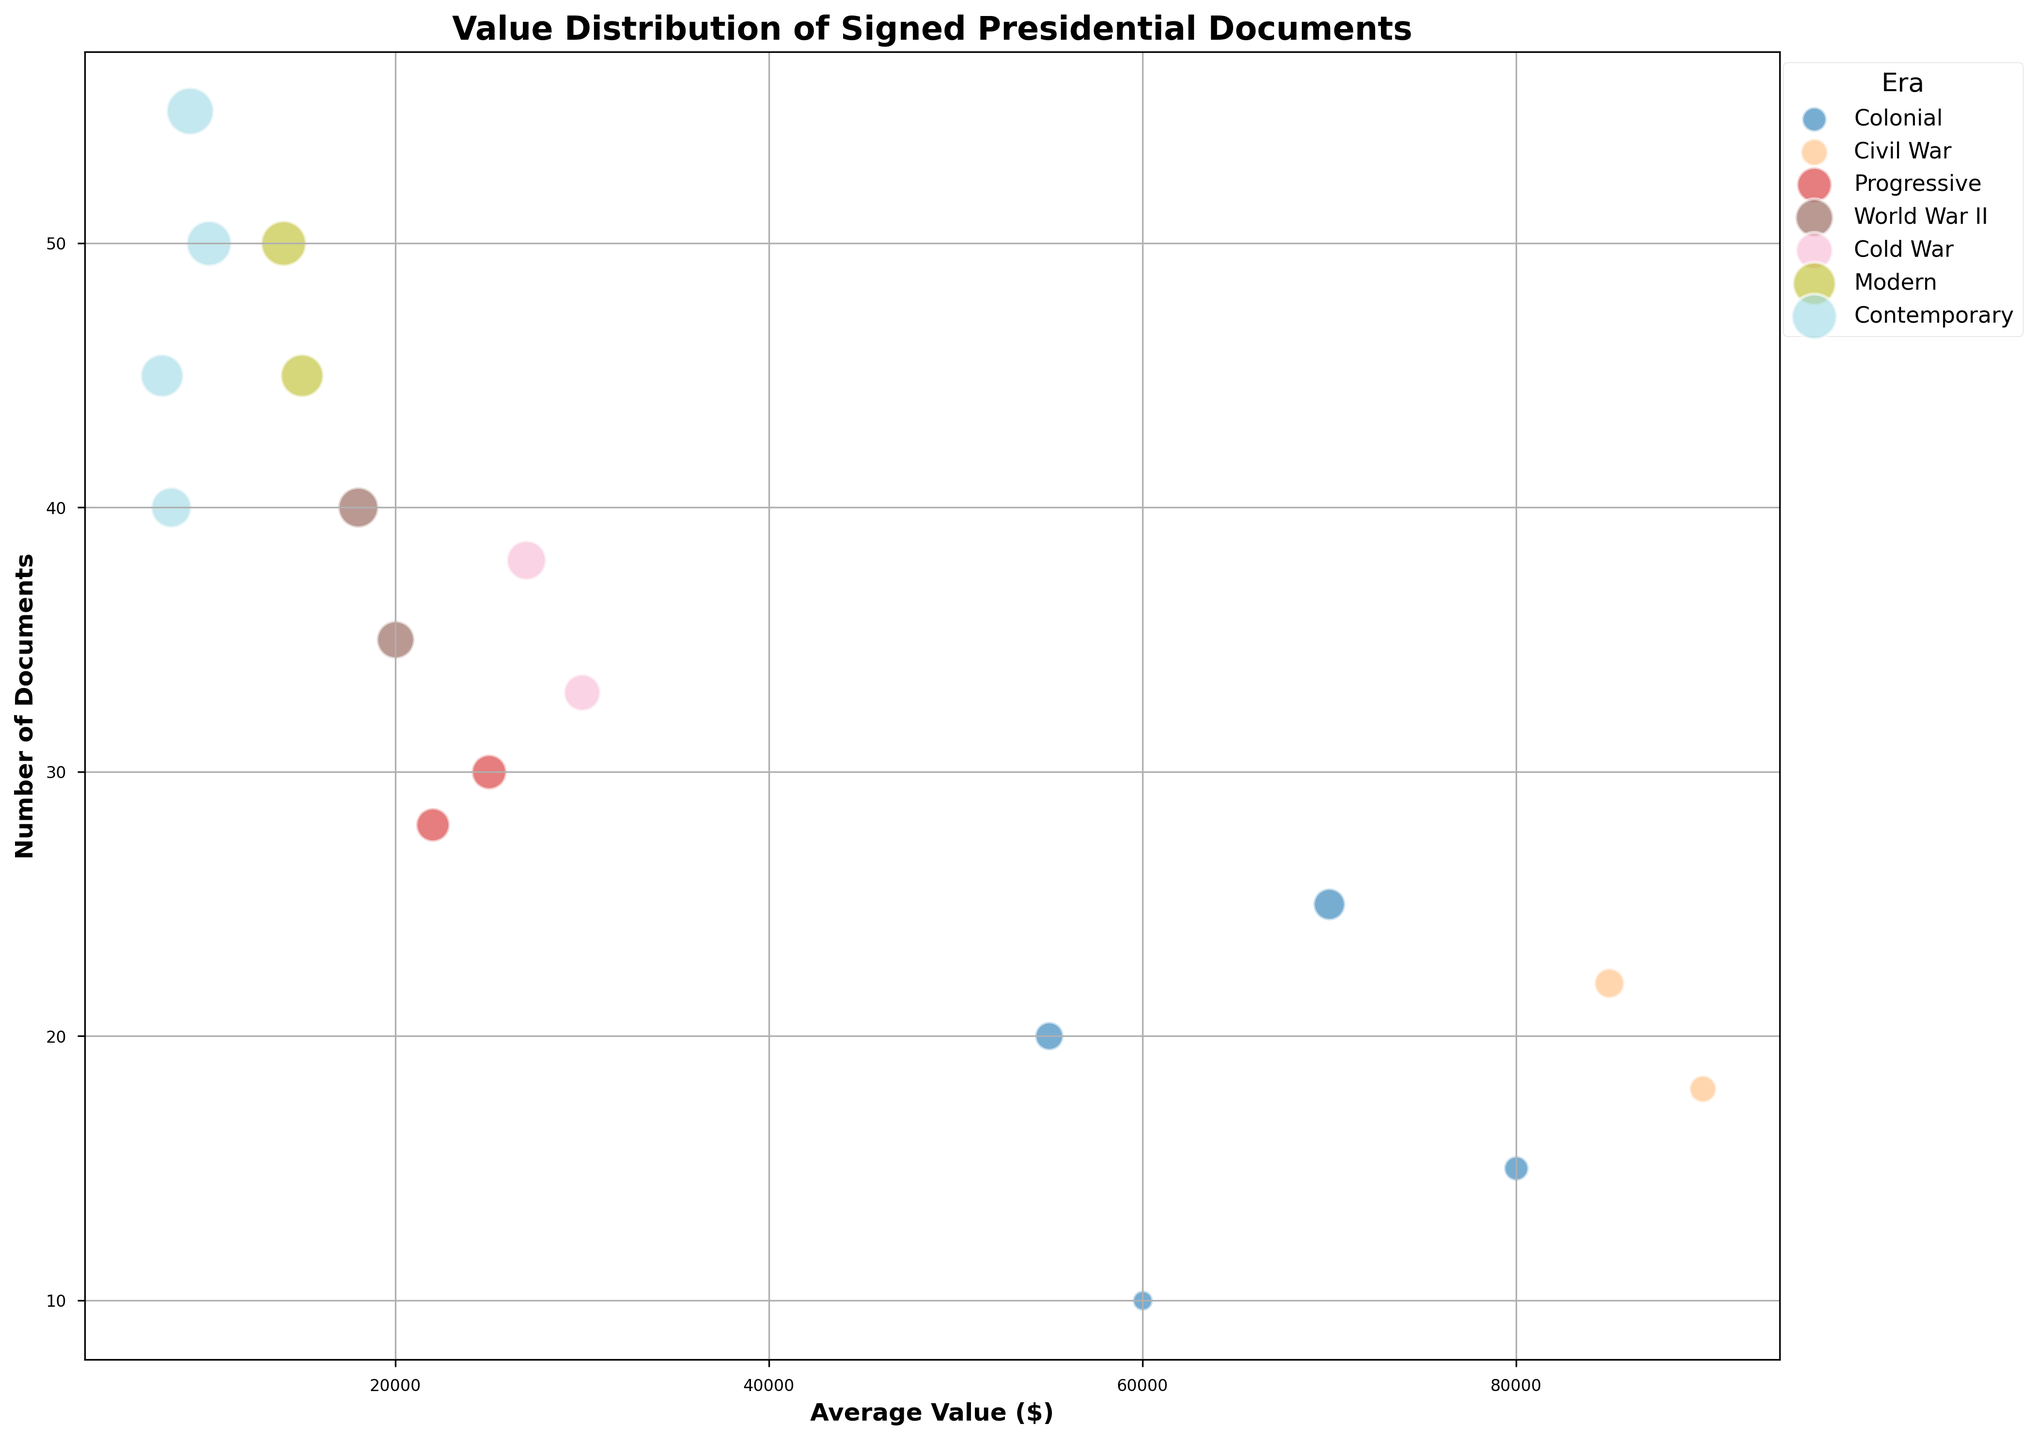What era has the highest number of signed documents? The number of documents is represented by the position along the y-axis. The cluster with the highest y-axis values for documents, regardless of the x-axis values, represents the era with the most documents. By examining the bubble positions, "Contemporary" has both Barack Obama and Donald Trump with higher numbers of documents compared to other eras.
Answer: Contemporary Which type of document signed by George Washington has a higher average value? There are two types of documents for George Washington: Proclamation and Letter. By looking at their positions along the x-axis which indicates the average value, Proclamation has a higher average value compared to Letter.
Answer: Proclamation How does the average value of signed documents by Abraham Lincoln compare to those by Theodore Roosevelt? Compare the x-axis values for both Proclamation and Letter documents of Abraham Lincoln and Theodore Roosevelt. Abraham Lincoln's documents (both types) have higher average values than all documents of Theodore Roosevelt.
Answer: Higher Which era shows a wider spread of values between Proclamation and Letter documents? To determine the spread of values, look at the x-axis difference between Proclamation and Letter documents within an era. Greater differences in horizontal positions indicate a wider spread. The Colonial era (George Washington and Thomas Jefferson) shows a noticeable wider spread compared to others.
Answer: Colonial Is the number of signed documents from Franklin D. Roosevelt more than from John F. Kennedy? Look at the y-axis values for both Franklin D. Roosevelt and John F. Kennedy. Franklin D. Roosevelt's cluster of bubbles is higher up the y-axis compared to John F. Kennedy, indicating more signed documents.
Answer: Yes Among contemporary presidents, whose letters have higher average value, Barack Obama or Donald Trump? Look at the x-axis values for Letter documents by Barack Obama and Donald Trump. Barack Obama’s letters have higher average values compared to Donald Trump's.
Answer: Barack Obama What's the smallest average value of signed documents, and which president does it belong to? Identify the bubbles with the furthest left on the x-axis for the average value. Donald Trump's Letter documents are positioned to the far left, indicating the smallest average value.
Answer: Donald Trump Compare the number of documents signed by Theodore Roosevelt to those signed by Ronald Reagan. Examine the y-axis values for both Theodore Roosevelt and Ronald Reagan's documents. Ronald Reagan’s bubbles are placed higher up the y-axis, indicating a greater number of documents compared to Theodore Roosevelt.
Answer: More Which president’s documents this are all valued at above $50,000? Check the bubbles above the $50,000 mark on the x-axis representing average value. George Washington and Abraham Lincoln’s documents are all valued above $50,000.
Answer: George Washington and Abraham Lincoln 